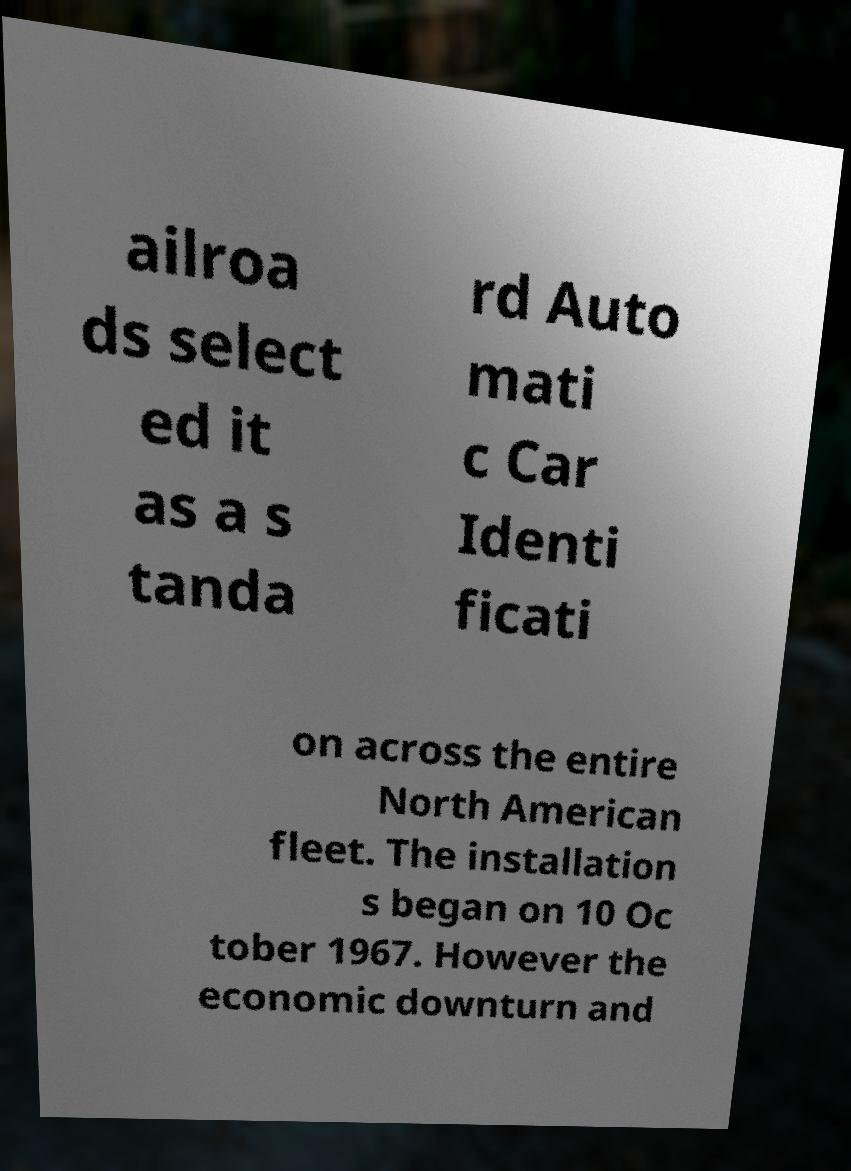Could you extract and type out the text from this image? ailroa ds select ed it as a s tanda rd Auto mati c Car Identi ficati on across the entire North American fleet. The installation s began on 10 Oc tober 1967. However the economic downturn and 